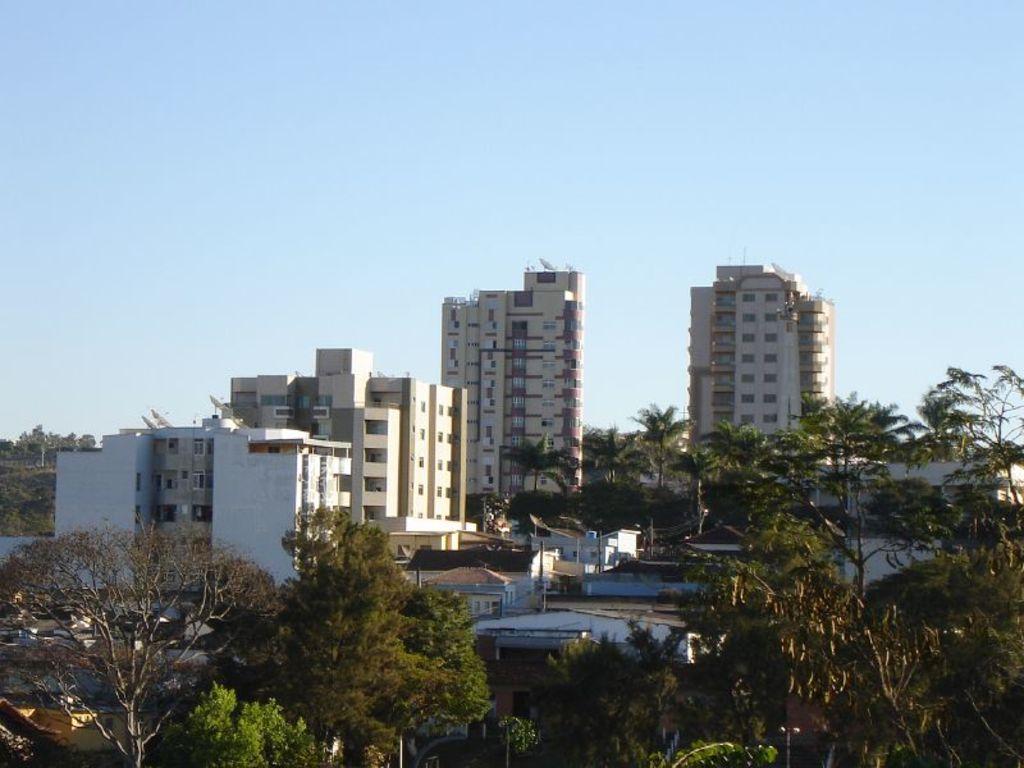In one or two sentences, can you explain what this image depicts? In this picture there are buildings and trees and there are poles and there are wires on the poles. At the top there is sky. There are television dishes on the top of the buildings. 